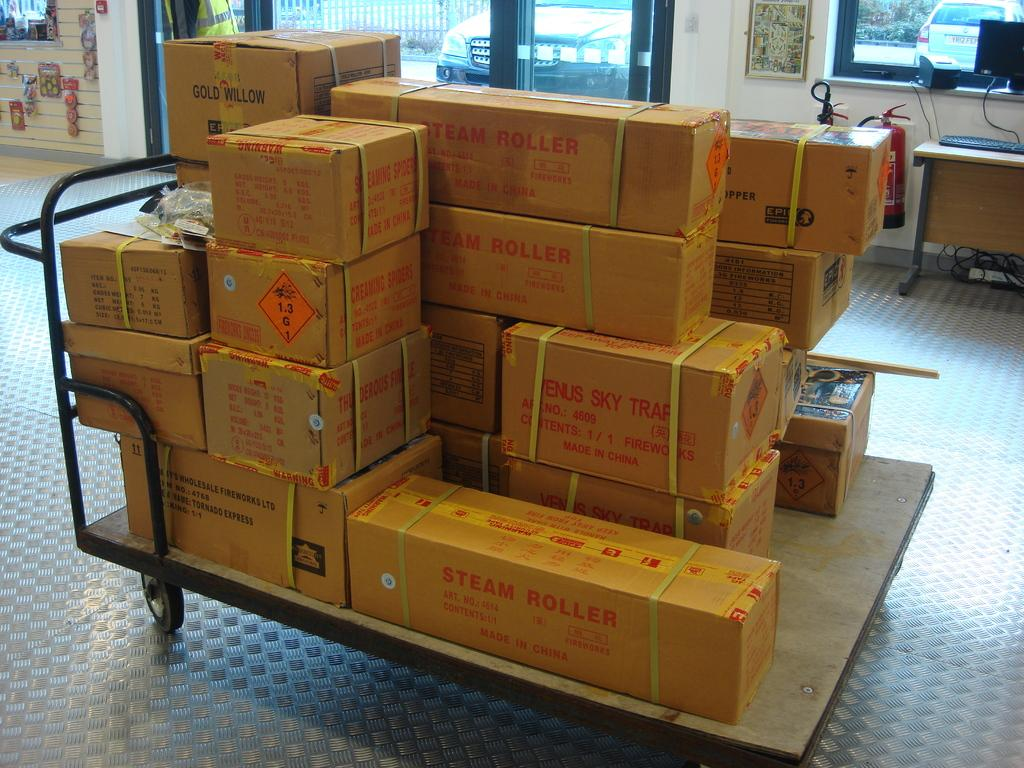<image>
Summarize the visual content of the image. A collection of boxes sit on a wheeled cart, one of them labeled steam roller. 